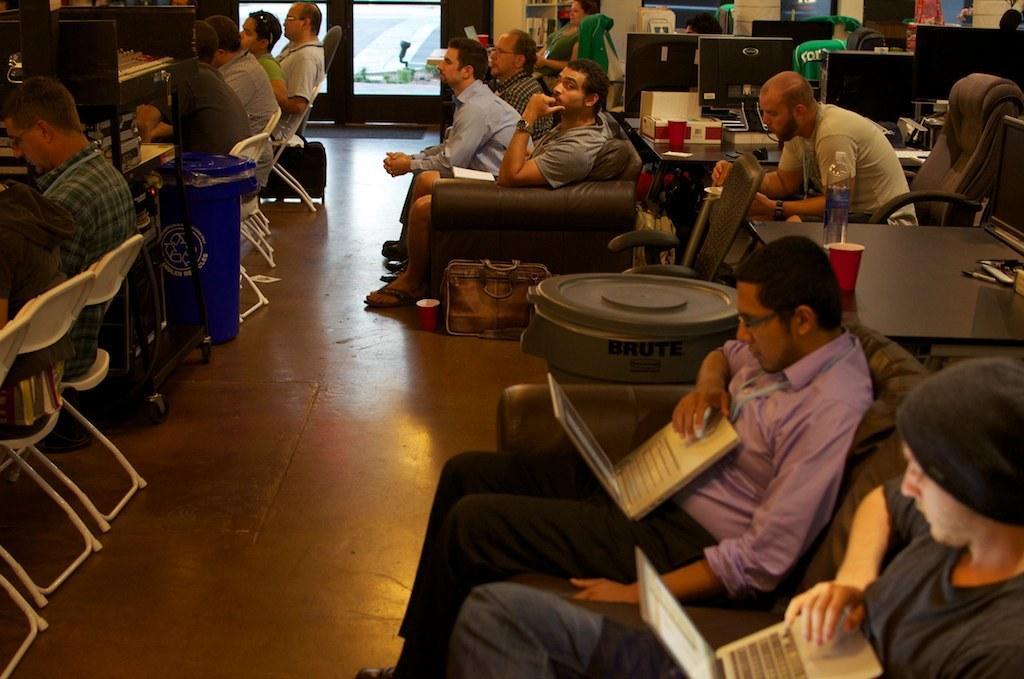Please provide a concise description of this image. In this image I can see people sitting on chairs and sofas. Some of them are holding laptops. Here I can see a table which has bottle, glass and other objects on it. In the background I can see monitors and some other objects on the floor. 